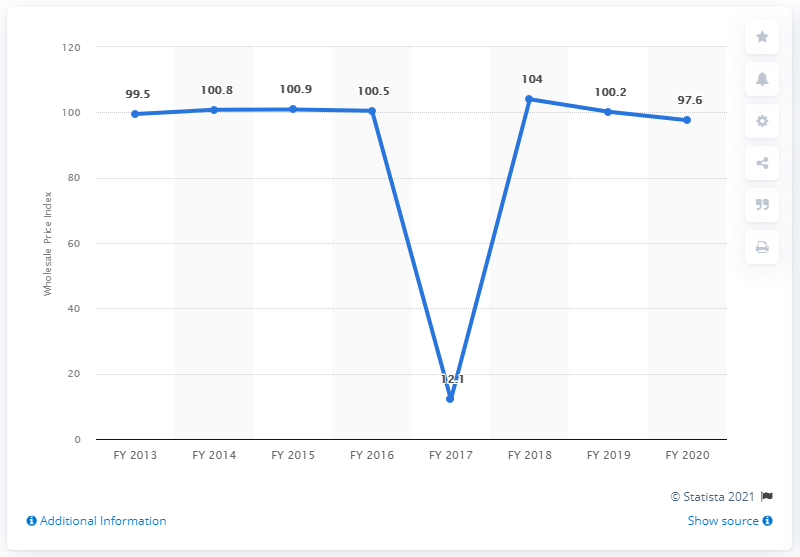Mention a couple of crucial points in this snapshot. The difference in the wholesale price between the financial years 2013 and 2019 is 0.7%. The wholesale price of consumer electronics in the financial year 2020 was approximately 97.6% of its retail price. 